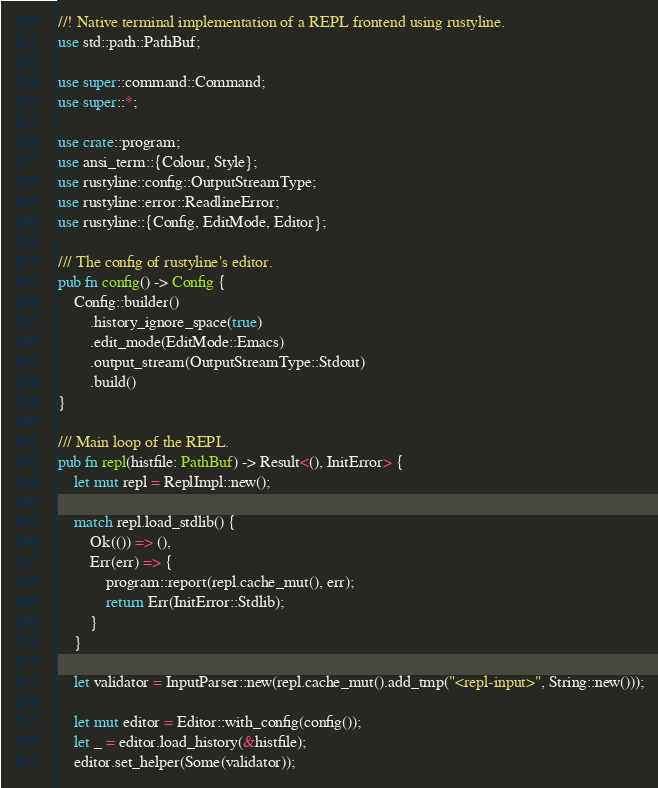Convert code to text. <code><loc_0><loc_0><loc_500><loc_500><_Rust_>//! Native terminal implementation of a REPL frontend using rustyline.
use std::path::PathBuf;

use super::command::Command;
use super::*;

use crate::program;
use ansi_term::{Colour, Style};
use rustyline::config::OutputStreamType;
use rustyline::error::ReadlineError;
use rustyline::{Config, EditMode, Editor};

/// The config of rustyline's editor.
pub fn config() -> Config {
    Config::builder()
        .history_ignore_space(true)
        .edit_mode(EditMode::Emacs)
        .output_stream(OutputStreamType::Stdout)
        .build()
}

/// Main loop of the REPL.
pub fn repl(histfile: PathBuf) -> Result<(), InitError> {
    let mut repl = ReplImpl::new();

    match repl.load_stdlib() {
        Ok(()) => (),
        Err(err) => {
            program::report(repl.cache_mut(), err);
            return Err(InitError::Stdlib);
        }
    }

    let validator = InputParser::new(repl.cache_mut().add_tmp("<repl-input>", String::new()));

    let mut editor = Editor::with_config(config());
    let _ = editor.load_history(&histfile);
    editor.set_helper(Some(validator));</code> 